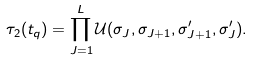<formula> <loc_0><loc_0><loc_500><loc_500>\tau _ { 2 } ( t _ { q } ) = \prod _ { J = 1 } ^ { L } \mathcal { U } ( \sigma _ { J } , \sigma _ { J + 1 } , \sigma ^ { \prime } _ { J + 1 } , \sigma ^ { \prime } _ { J } ) .</formula> 